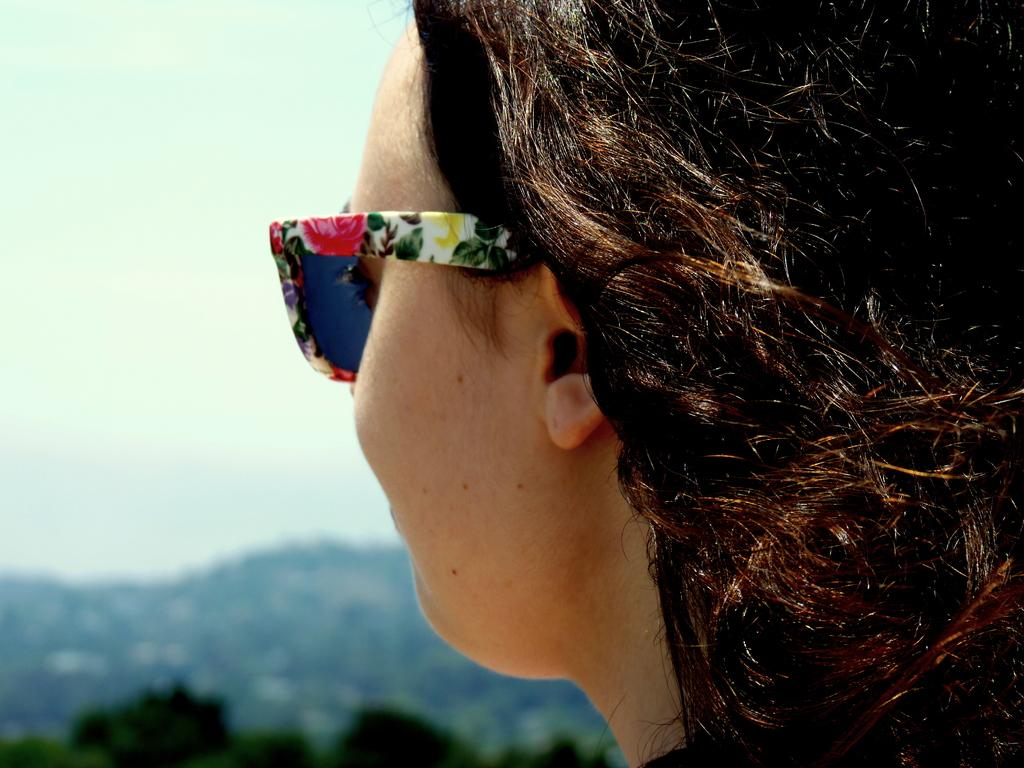Who is present in the image? There is a woman in the image. What is the woman wearing on her face? The woman is wearing shades. What can be seen in the background of the image? There are trees and the sky visible in the background of the image. How is the background of the image depicted? The background of the image is blurred. What type of jelly can be seen hanging from the trees in the image? There is no jelly present in the image, and therefore no such activity can be observed. 